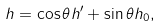Convert formula to latex. <formula><loc_0><loc_0><loc_500><loc_500>h = \cos \theta h ^ { \prime } + \sin \theta h _ { 0 } ,</formula> 